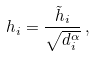<formula> <loc_0><loc_0><loc_500><loc_500>h _ { i } = \frac { \tilde { h } _ { i } } { \sqrt { d _ { i } ^ { \alpha } } } \, ,</formula> 